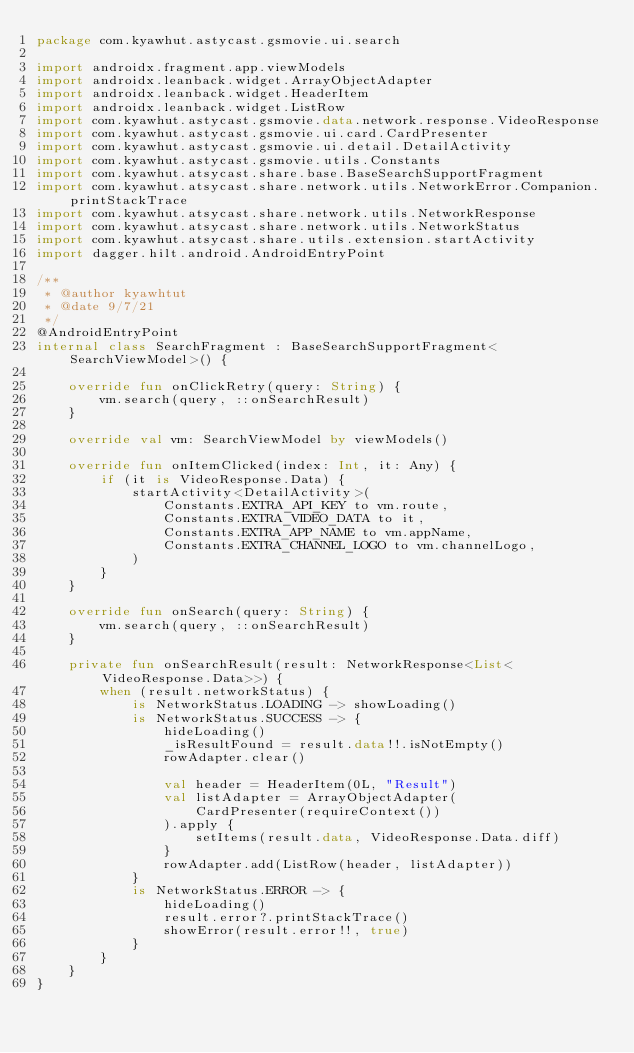<code> <loc_0><loc_0><loc_500><loc_500><_Kotlin_>package com.kyawhut.astycast.gsmovie.ui.search

import androidx.fragment.app.viewModels
import androidx.leanback.widget.ArrayObjectAdapter
import androidx.leanback.widget.HeaderItem
import androidx.leanback.widget.ListRow
import com.kyawhut.astycast.gsmovie.data.network.response.VideoResponse
import com.kyawhut.astycast.gsmovie.ui.card.CardPresenter
import com.kyawhut.astycast.gsmovie.ui.detail.DetailActivity
import com.kyawhut.astycast.gsmovie.utils.Constants
import com.kyawhut.atsycast.share.base.BaseSearchSupportFragment
import com.kyawhut.atsycast.share.network.utils.NetworkError.Companion.printStackTrace
import com.kyawhut.atsycast.share.network.utils.NetworkResponse
import com.kyawhut.atsycast.share.network.utils.NetworkStatus
import com.kyawhut.atsycast.share.utils.extension.startActivity
import dagger.hilt.android.AndroidEntryPoint

/**
 * @author kyawhtut
 * @date 9/7/21
 */
@AndroidEntryPoint
internal class SearchFragment : BaseSearchSupportFragment<SearchViewModel>() {

    override fun onClickRetry(query: String) {
        vm.search(query, ::onSearchResult)
    }

    override val vm: SearchViewModel by viewModels()

    override fun onItemClicked(index: Int, it: Any) {
        if (it is VideoResponse.Data) {
            startActivity<DetailActivity>(
                Constants.EXTRA_API_KEY to vm.route,
                Constants.EXTRA_VIDEO_DATA to it,
                Constants.EXTRA_APP_NAME to vm.appName,
                Constants.EXTRA_CHANNEL_LOGO to vm.channelLogo,
            )
        }
    }

    override fun onSearch(query: String) {
        vm.search(query, ::onSearchResult)
    }

    private fun onSearchResult(result: NetworkResponse<List<VideoResponse.Data>>) {
        when (result.networkStatus) {
            is NetworkStatus.LOADING -> showLoading()
            is NetworkStatus.SUCCESS -> {
                hideLoading()
                _isResultFound = result.data!!.isNotEmpty()
                rowAdapter.clear()

                val header = HeaderItem(0L, "Result")
                val listAdapter = ArrayObjectAdapter(
                    CardPresenter(requireContext())
                ).apply {
                    setItems(result.data, VideoResponse.Data.diff)
                }
                rowAdapter.add(ListRow(header, listAdapter))
            }
            is NetworkStatus.ERROR -> {
                hideLoading()
                result.error?.printStackTrace()
                showError(result.error!!, true)
            }
        }
    }
}
</code> 